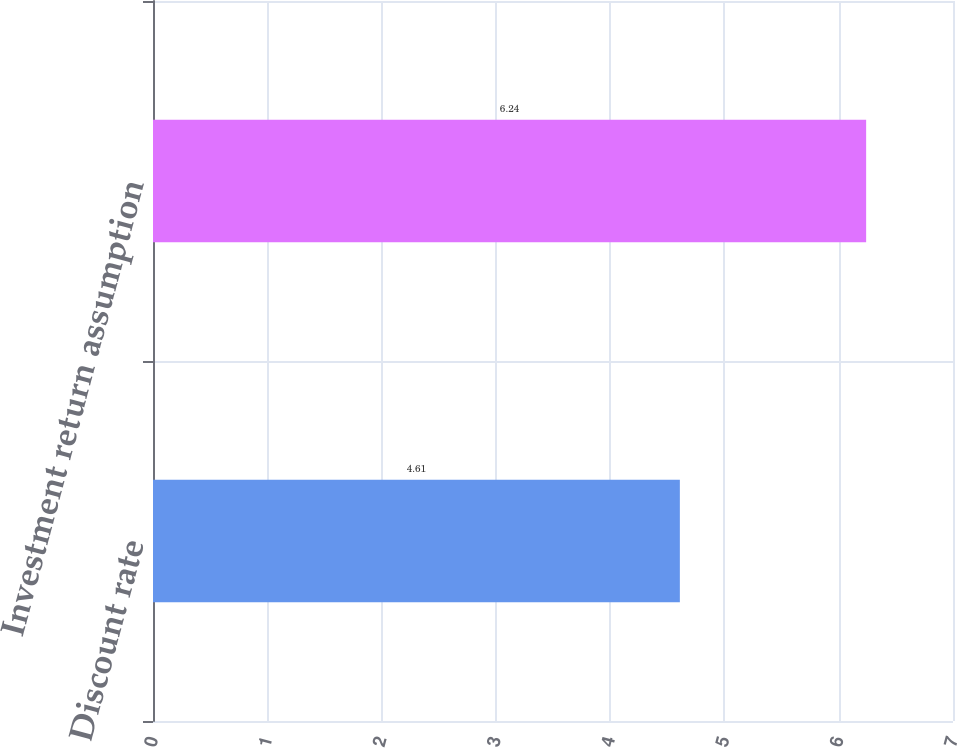Convert chart to OTSL. <chart><loc_0><loc_0><loc_500><loc_500><bar_chart><fcel>Discount rate<fcel>Investment return assumption<nl><fcel>4.61<fcel>6.24<nl></chart> 